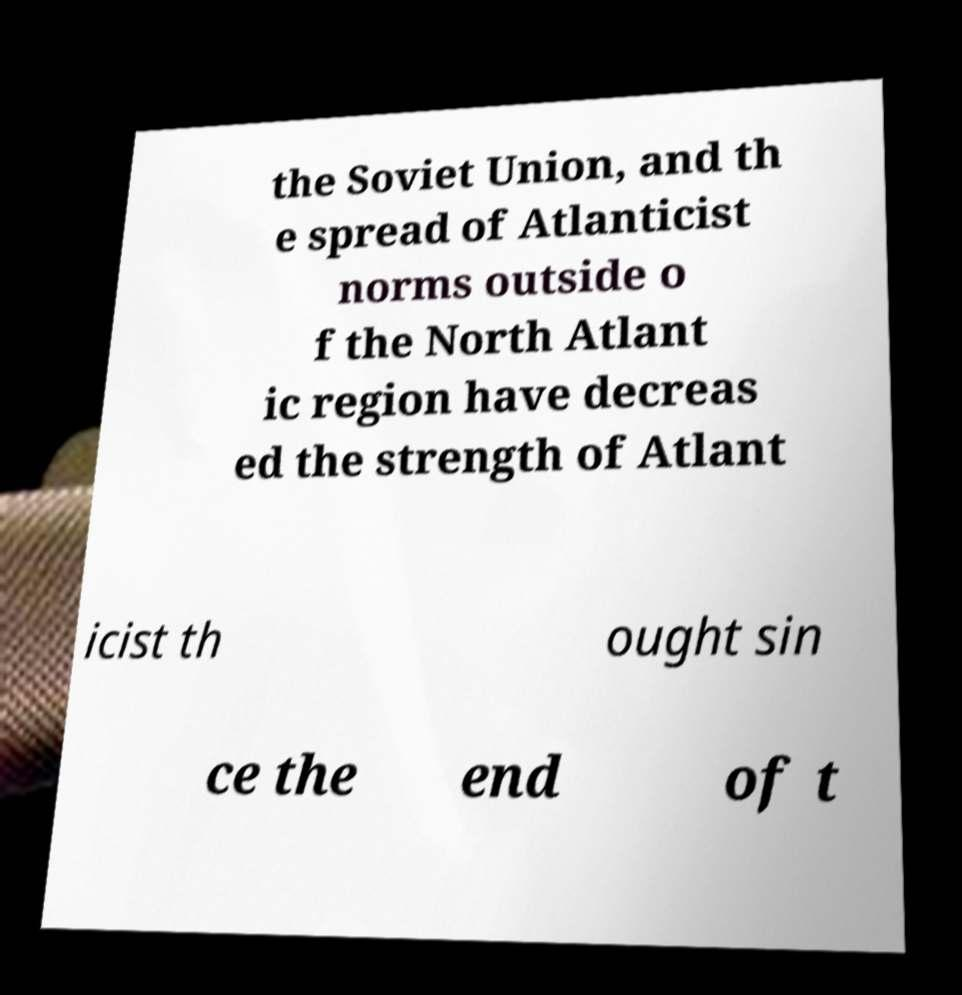Could you extract and type out the text from this image? the Soviet Union, and th e spread of Atlanticist norms outside o f the North Atlant ic region have decreas ed the strength of Atlant icist th ought sin ce the end of t 